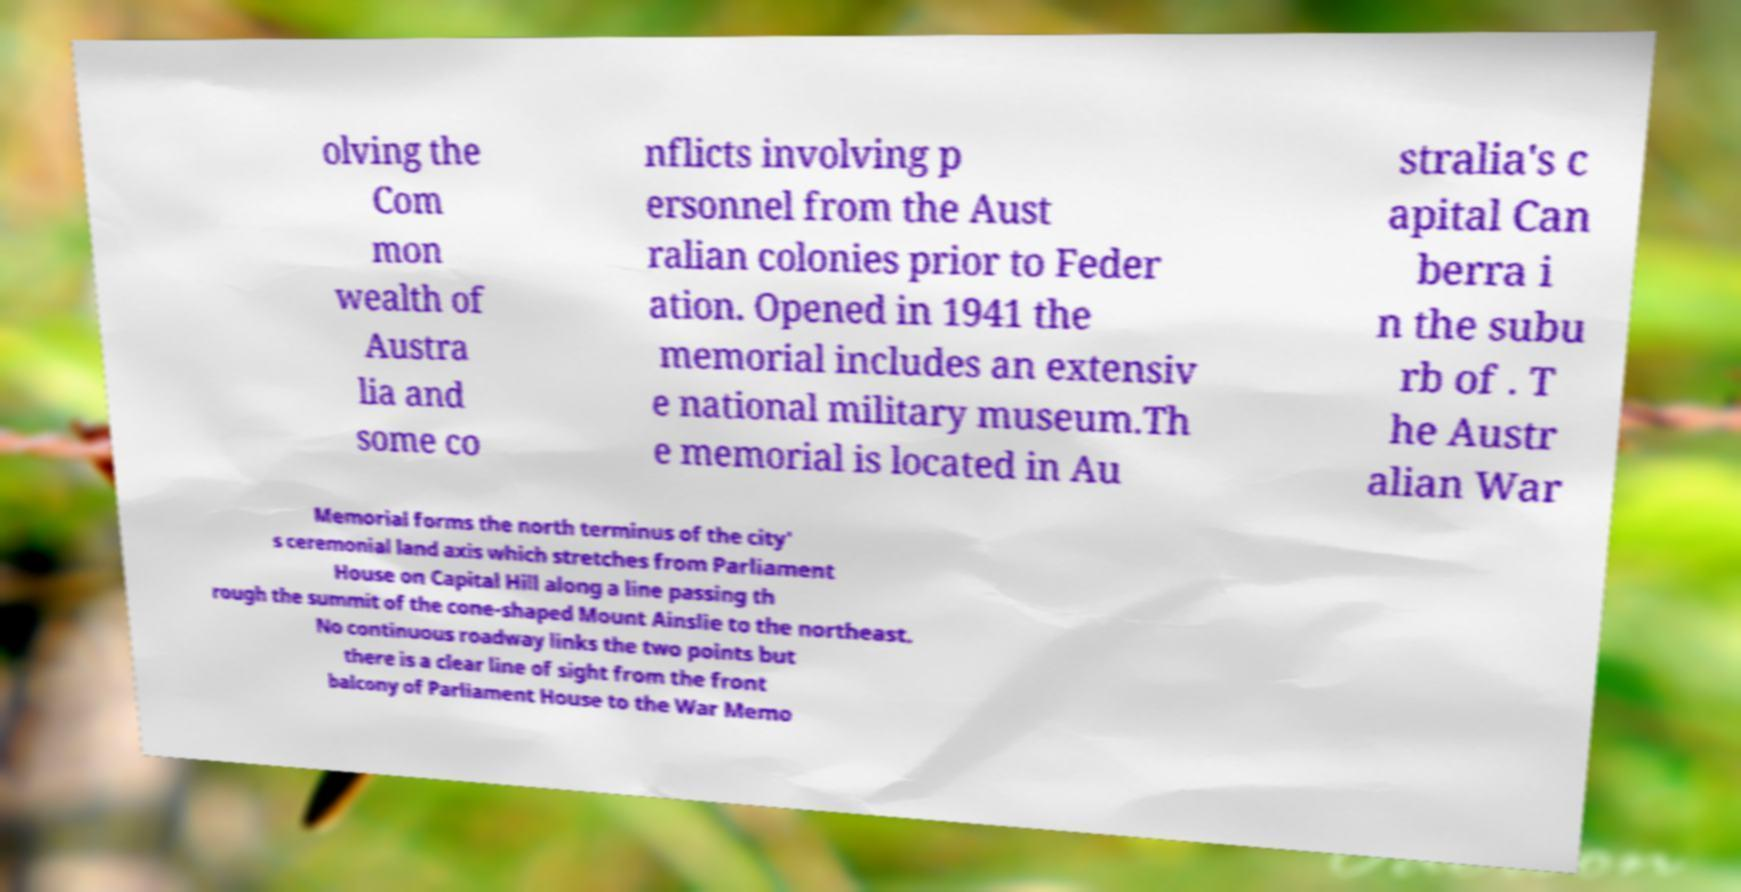Please read and relay the text visible in this image. What does it say? olving the Com mon wealth of Austra lia and some co nflicts involving p ersonnel from the Aust ralian colonies prior to Feder ation. Opened in 1941 the memorial includes an extensiv e national military museum.Th e memorial is located in Au stralia's c apital Can berra i n the subu rb of . T he Austr alian War Memorial forms the north terminus of the city' s ceremonial land axis which stretches from Parliament House on Capital Hill along a line passing th rough the summit of the cone-shaped Mount Ainslie to the northeast. No continuous roadway links the two points but there is a clear line of sight from the front balcony of Parliament House to the War Memo 